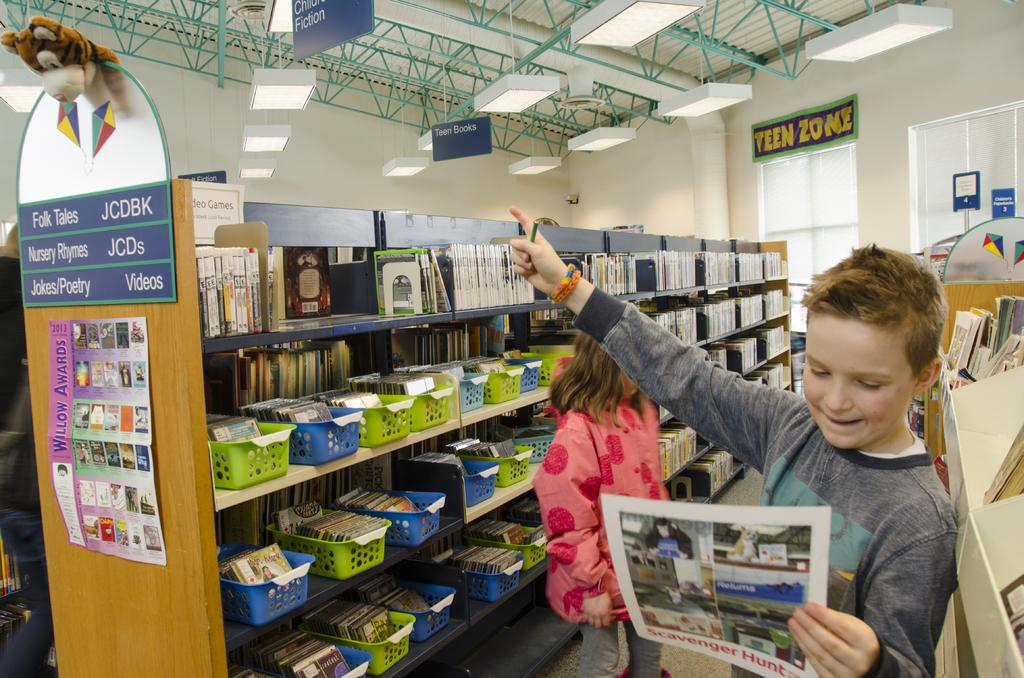<image>
Create a compact narrative representing the image presented. A kid looking at a paper and pointing at something in an aisle of Folk Tales and Nursery Rhymes. 